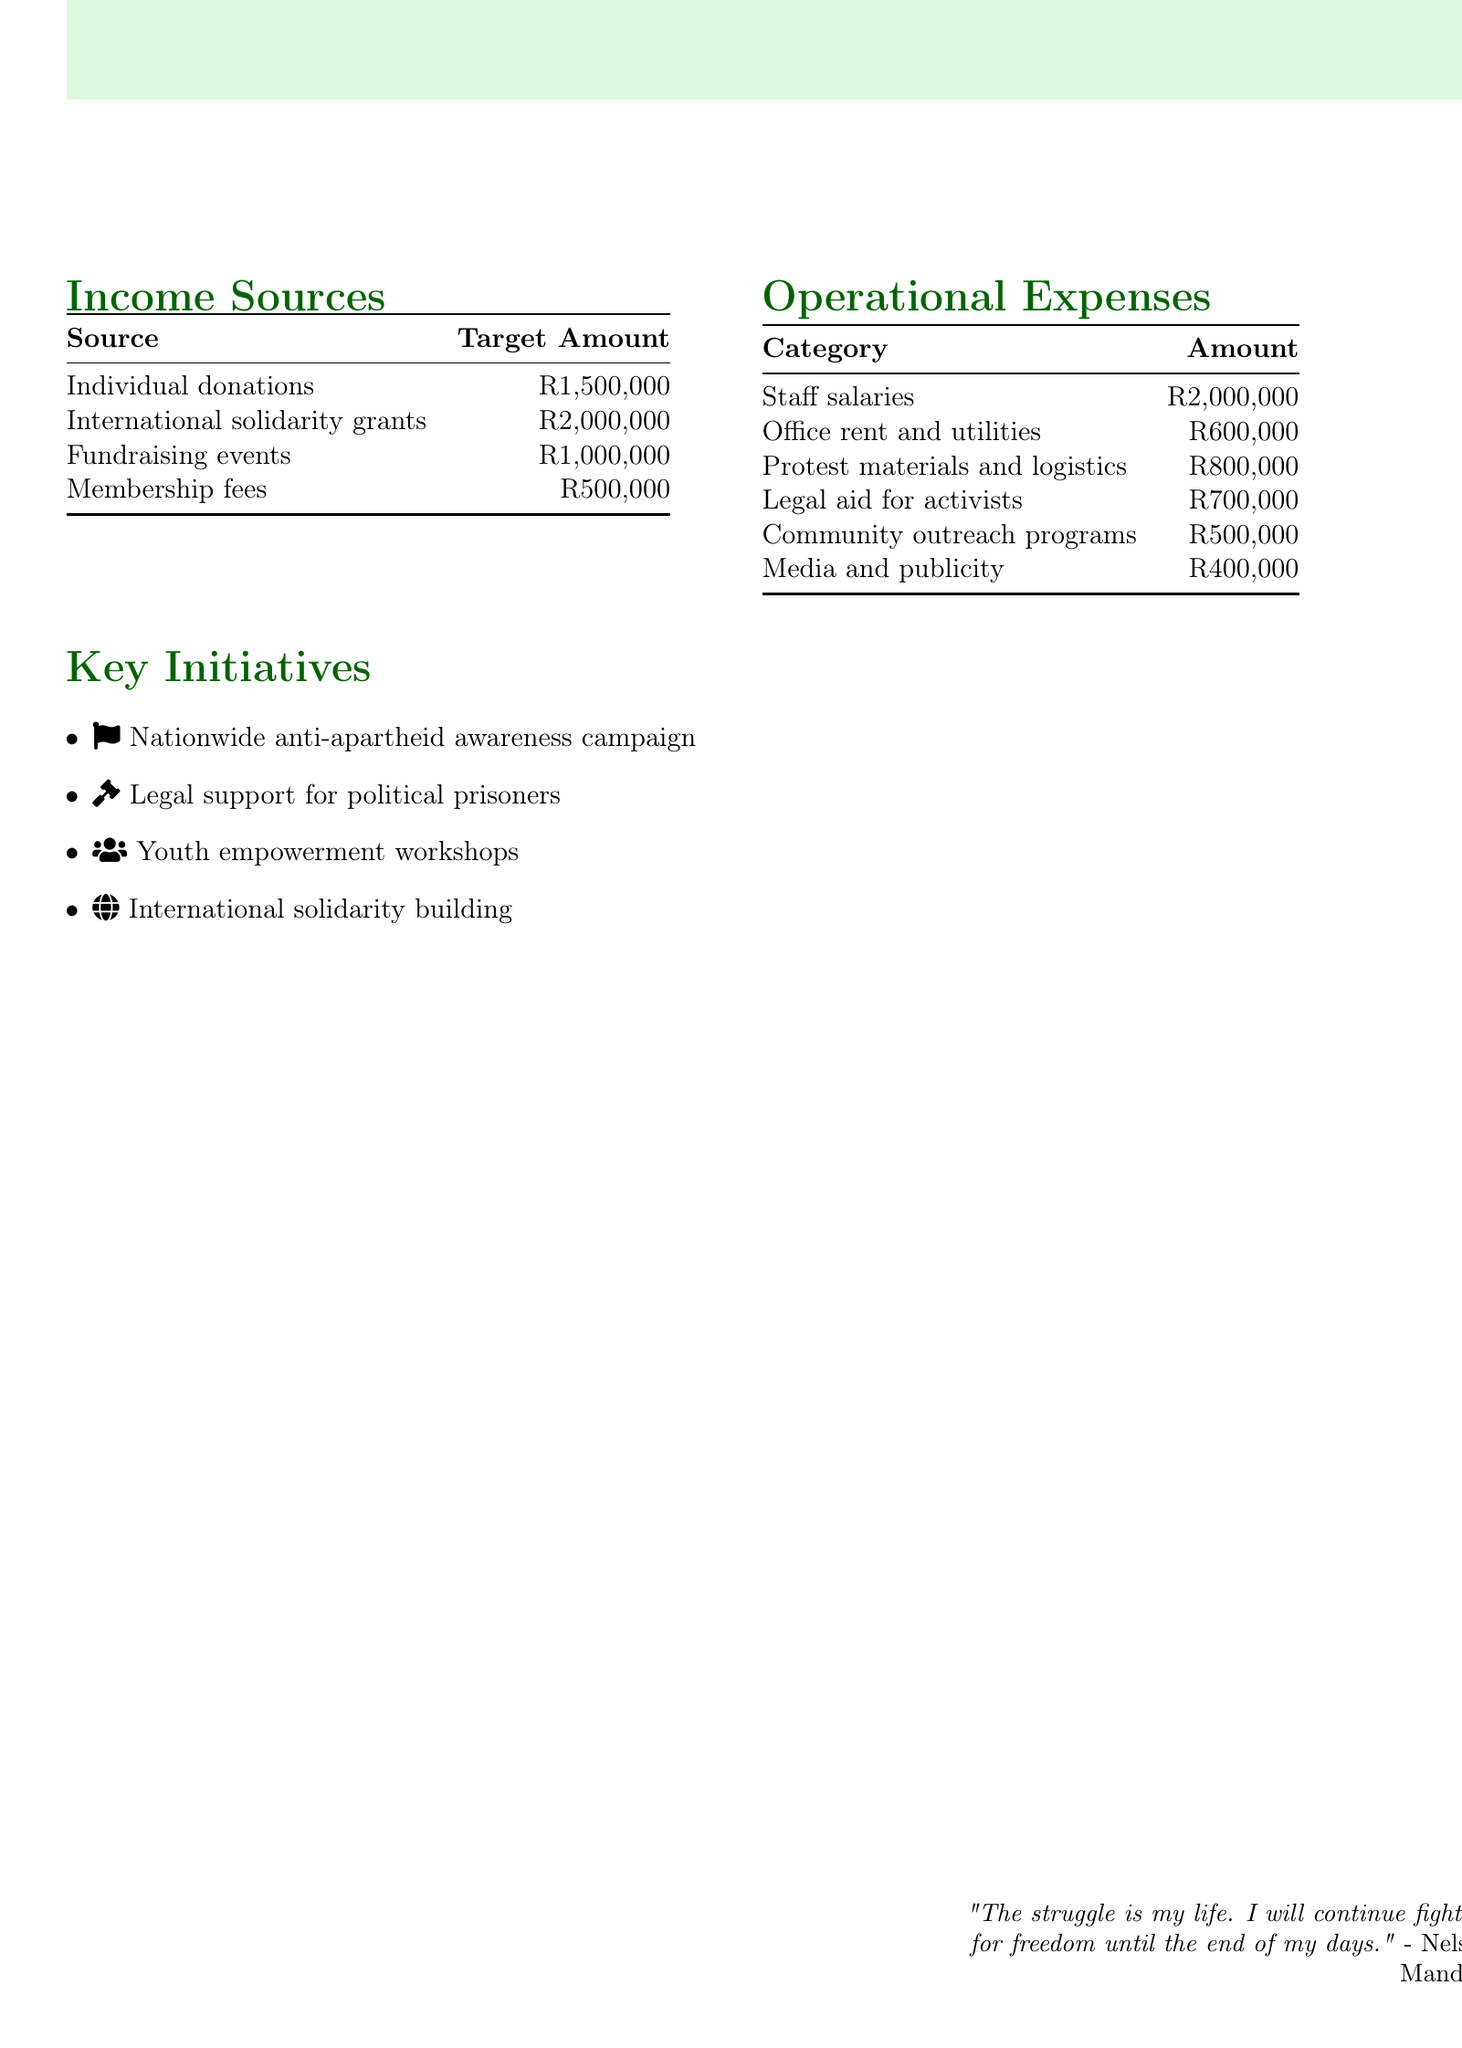What is the total budget for 2023-2024? The total budget for the year is stated in the document as R5,000,000.
Answer: R5,000,000 How much is expected from individual donations? The document specifies R1,500,000 as the target amount from individual donations.
Answer: R1,500,000 What is the budget for legal aid for activists? The paragraph on operational expenses indicates that R700,000 is allocated for legal aid for activists.
Answer: R700,000 What percentage of the budget is allocated for staff salaries? Staff salaries are R2,000,000, which makes up 40% of the total budget of R5,000,000.
Answer: 40% Which initiative focuses on international cooperation? The key initiative that emphasizes international cooperation is named "International solidarity building."
Answer: International solidarity building What is the total amount expected from fundraising events? According to the income sources, the total expected from fundraising events is R1,000,000.
Answer: R1,000,000 Which category has the highest expense? The highest expense listed under operational expenses is for staff salaries, totaling R2,000,000.
Answer: Staff salaries How much is budgeted for community outreach programs? The operational expenses section shows that R500,000 is budgeted for community outreach programs.
Answer: R500,000 What type of campaign is prioritized in the key initiatives? The key initiative prioritized in the document is a "Nationwide anti-apartheid awareness campaign."
Answer: Nationwide anti-apartheid awareness campaign 